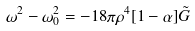Convert formula to latex. <formula><loc_0><loc_0><loc_500><loc_500>\omega ^ { 2 } - \omega ^ { 2 } _ { 0 } = - 1 8 \pi \rho ^ { 4 } [ 1 - \alpha ] \tilde { G }</formula> 